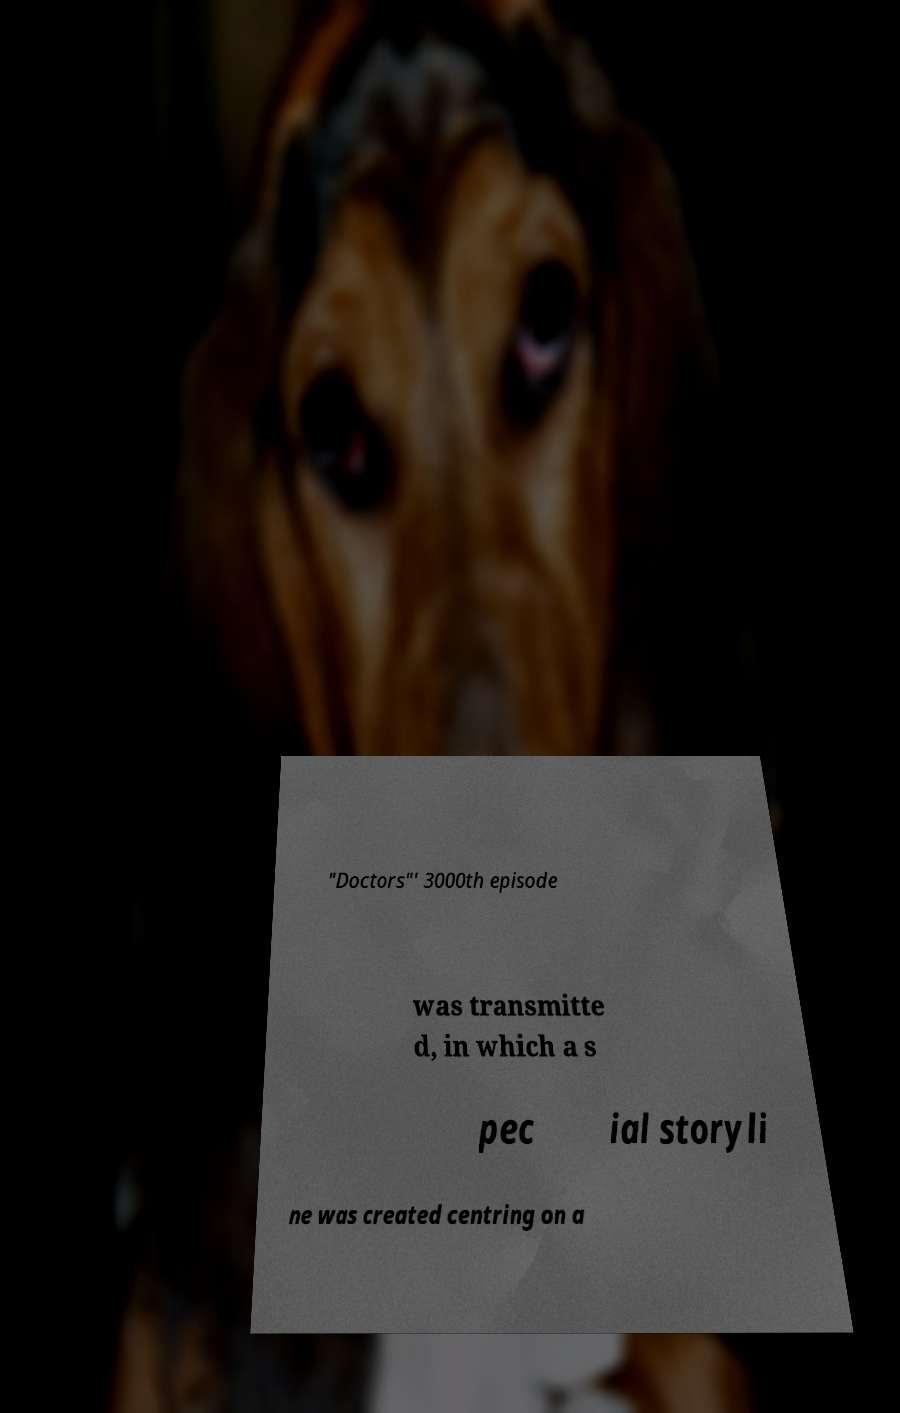Can you read and provide the text displayed in the image?This photo seems to have some interesting text. Can you extract and type it out for me? "Doctors"' 3000th episode was transmitte d, in which a s pec ial storyli ne was created centring on a 